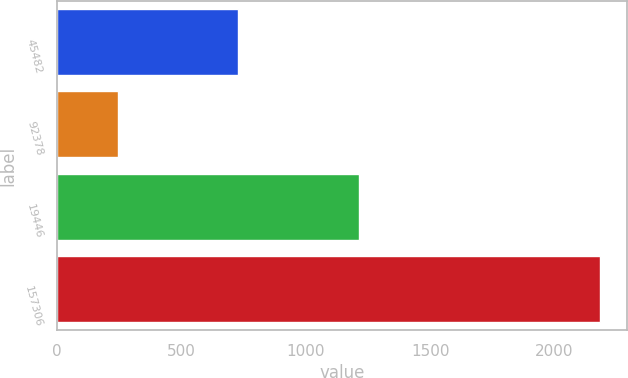Convert chart. <chart><loc_0><loc_0><loc_500><loc_500><bar_chart><fcel>45482<fcel>92378<fcel>19446<fcel>157306<nl><fcel>727<fcel>244<fcel>1212<fcel>2183<nl></chart> 